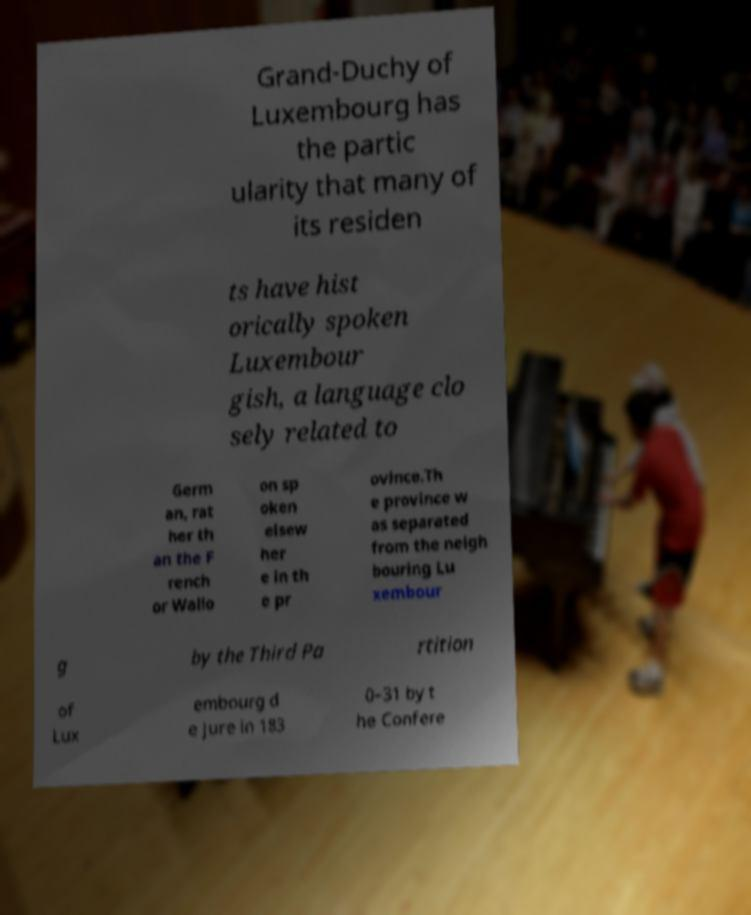There's text embedded in this image that I need extracted. Can you transcribe it verbatim? Grand-Duchy of Luxembourg has the partic ularity that many of its residen ts have hist orically spoken Luxembour gish, a language clo sely related to Germ an, rat her th an the F rench or Wallo on sp oken elsew her e in th e pr ovince.Th e province w as separated from the neigh bouring Lu xembour g by the Third Pa rtition of Lux embourg d e jure in 183 0–31 by t he Confere 